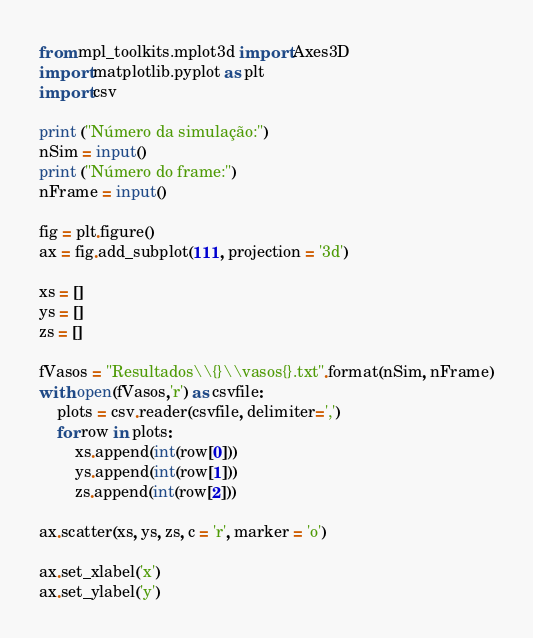<code> <loc_0><loc_0><loc_500><loc_500><_Python_>from mpl_toolkits.mplot3d import Axes3D
import matplotlib.pyplot as plt
import csv

print ("Número da simulação:")
nSim = input()
print ("Número do frame:")
nFrame = input()

fig = plt.figure()
ax = fig.add_subplot(111, projection = '3d')

xs = []
ys = []
zs = []

fVasos = "Resultados\\{}\\vasos{}.txt".format(nSim, nFrame)
with open(fVasos,'r') as csvfile:
    plots = csv.reader(csvfile, delimiter=',')
    for row in plots:
        xs.append(int(row[0]))
        ys.append(int(row[1]))
        zs.append(int(row[2]))

ax.scatter(xs, ys, zs, c = 'r', marker = 'o')

ax.set_xlabel('x')
ax.set_ylabel('y')</code> 